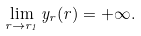<formula> <loc_0><loc_0><loc_500><loc_500>\lim _ { r \to r _ { 1 } } y _ { r } ( r ) = + \infty .</formula> 